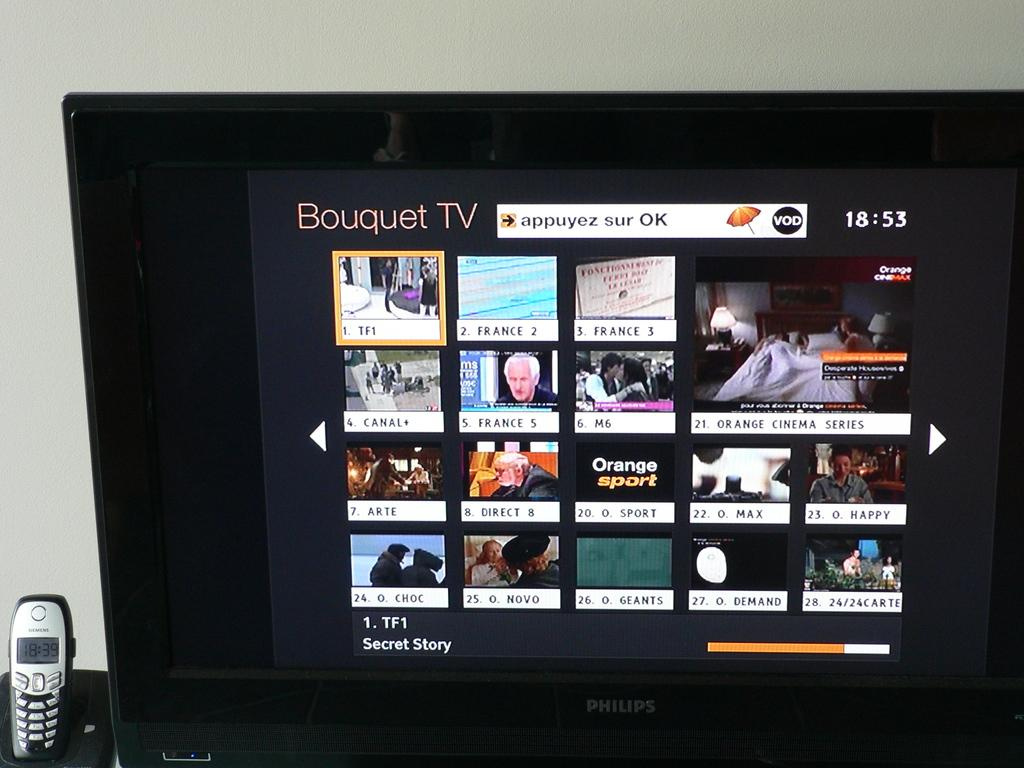<image>
Summarize the visual content of the image. Several movie options provided by Bouquet TV are displayed on a television screen. 